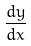Convert formula to latex. <formula><loc_0><loc_0><loc_500><loc_500>\frac { d y } { d x }</formula> 